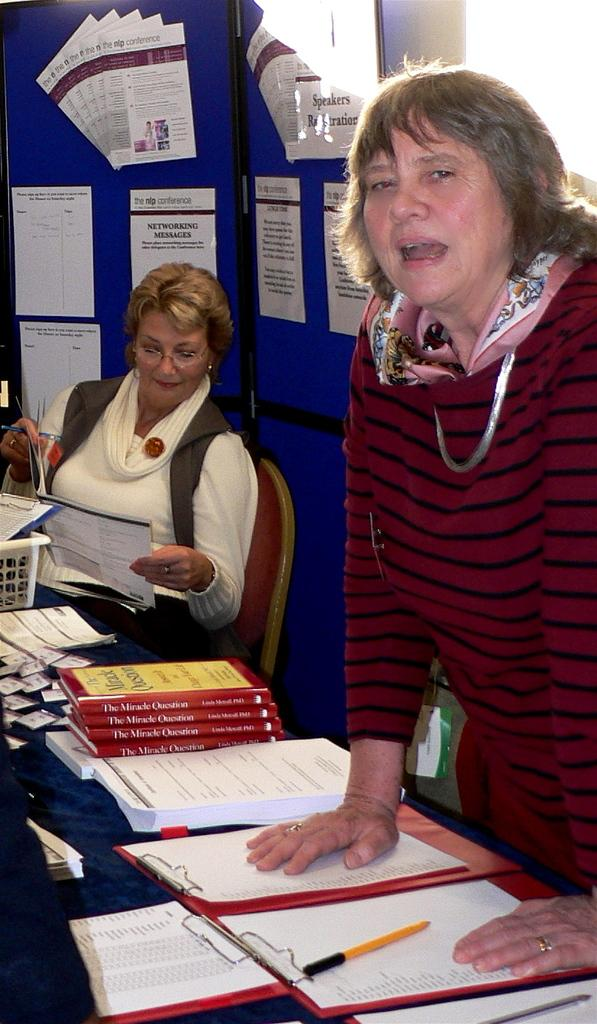<image>
Write a terse but informative summary of the picture. Two women sitting on a table with four copies of the book titled "The Miracle Question". 